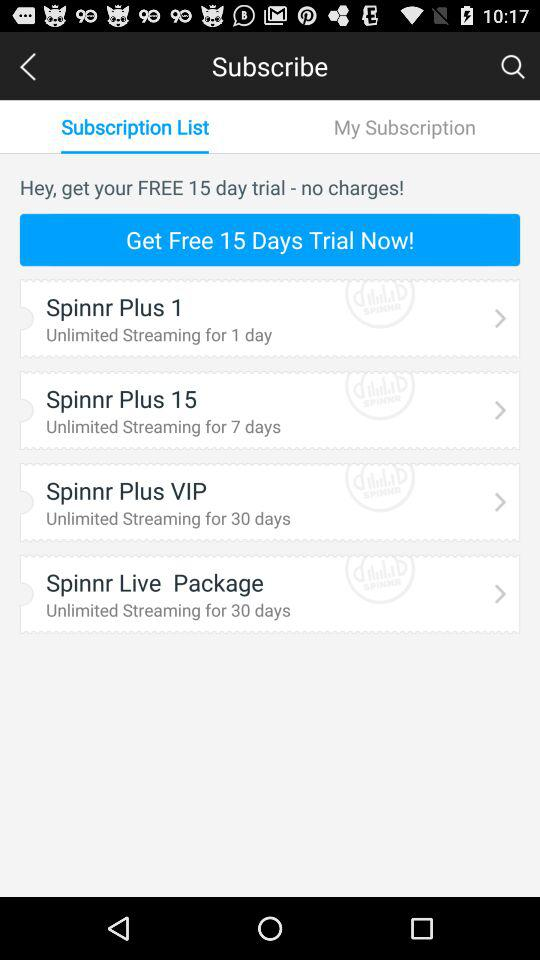How many days of streaming are included in the Spinnr Plus 1 package?
Answer the question using a single word or phrase. 1 day 